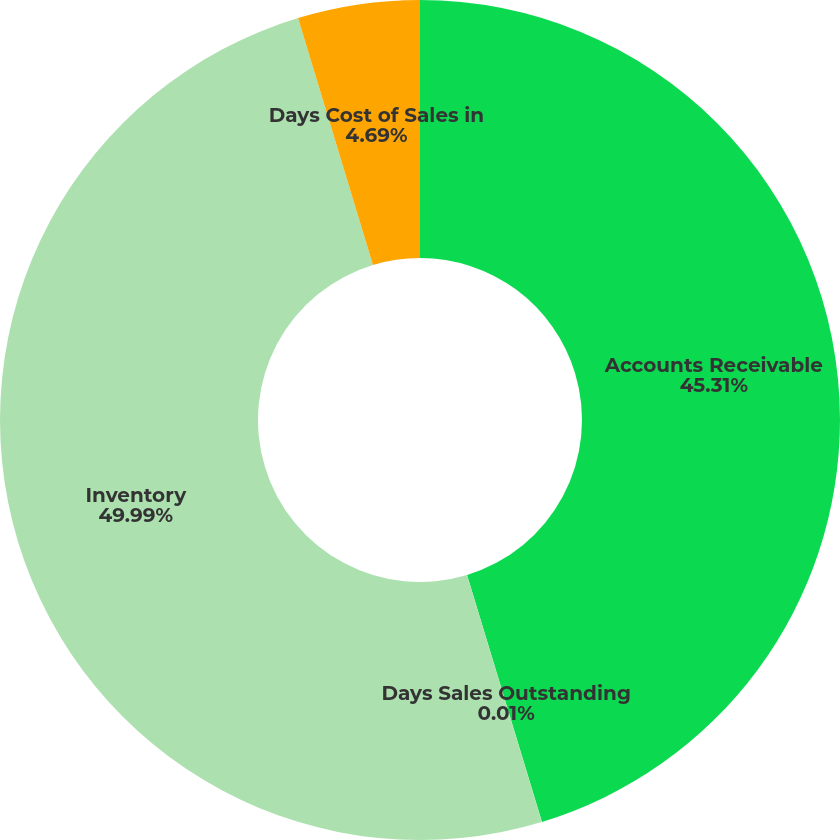Convert chart. <chart><loc_0><loc_0><loc_500><loc_500><pie_chart><fcel>Accounts Receivable<fcel>Days Sales Outstanding<fcel>Inventory<fcel>Days Cost of Sales in<nl><fcel>45.31%<fcel>0.01%<fcel>49.99%<fcel>4.69%<nl></chart> 